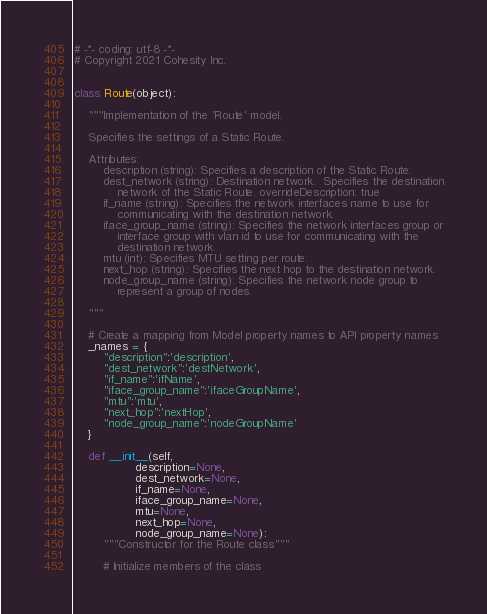<code> <loc_0><loc_0><loc_500><loc_500><_Python_># -*- coding: utf-8 -*-
# Copyright 2021 Cohesity Inc.


class Route(object):

    """Implementation of the 'Route' model.

    Specifies the settings of a Static Route.

    Attributes:
        description (string): Specifies a description of the Static Route.
        dest_network (string): Destination network.  Specifies the destination
            network of the Static Route. overrideDescription: true
        if_name (string): Specifies the network interfaces name to use for
            communicating with the destination network.
        iface_group_name (string): Specifies the network interfaces group or
            interface group with vlan id to use for communicating with the
            destination network.
        mtu (int): Specifies MTU setting per route.
        next_hop (string): Specifies the next hop to the destination network.
        node_group_name (string): Specifies the network node group to
            represent a group of nodes.

    """

    # Create a mapping from Model property names to API property names
    _names = {
        "description":'description',
        "dest_network":'destNetwork',
        "if_name":'ifName',
        "iface_group_name":'ifaceGroupName',
        "mtu":'mtu',
        "next_hop":'nextHop',
        "node_group_name":'nodeGroupName'
    }

    def __init__(self,
                 description=None,
                 dest_network=None,
                 if_name=None,
                 iface_group_name=None,
                 mtu=None,
                 next_hop=None,
                 node_group_name=None):
        """Constructor for the Route class"""

        # Initialize members of the class</code> 